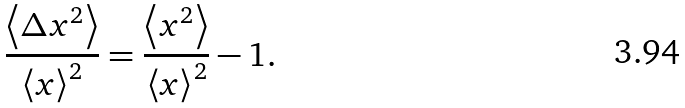<formula> <loc_0><loc_0><loc_500><loc_500>\frac { \left < \Delta x ^ { 2 } \right > } { \left < x \right > ^ { 2 } } = \frac { \left < x ^ { 2 } \right > } { \left < x \right > ^ { 2 } } - 1 .</formula> 